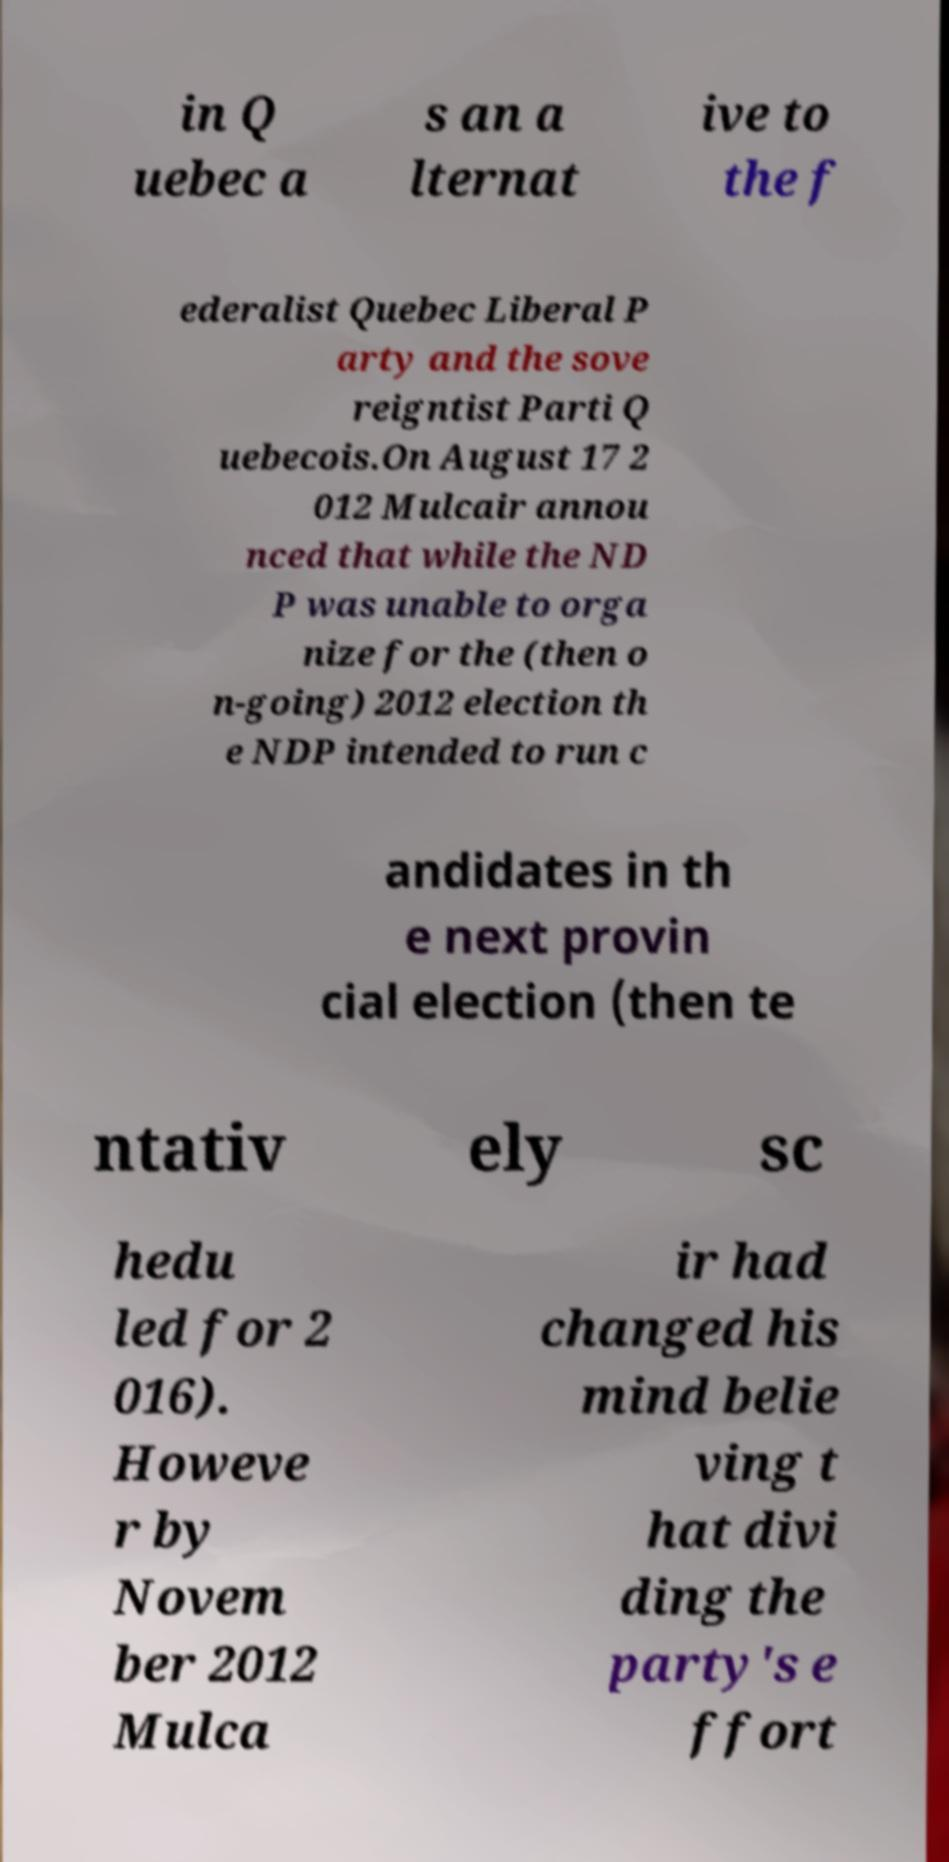Please read and relay the text visible in this image. What does it say? in Q uebec a s an a lternat ive to the f ederalist Quebec Liberal P arty and the sove reigntist Parti Q uebecois.On August 17 2 012 Mulcair annou nced that while the ND P was unable to orga nize for the (then o n-going) 2012 election th e NDP intended to run c andidates in th e next provin cial election (then te ntativ ely sc hedu led for 2 016). Howeve r by Novem ber 2012 Mulca ir had changed his mind belie ving t hat divi ding the party's e ffort 